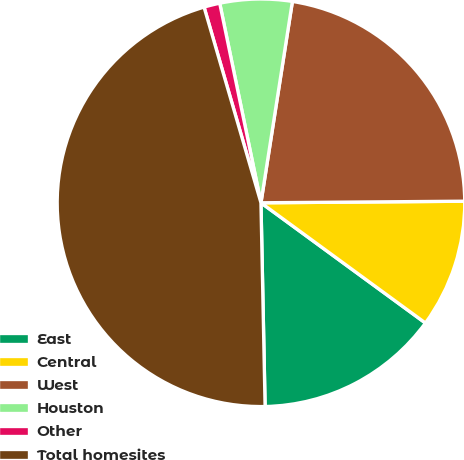<chart> <loc_0><loc_0><loc_500><loc_500><pie_chart><fcel>East<fcel>Central<fcel>West<fcel>Houston<fcel>Other<fcel>Total homesites<nl><fcel>14.63%<fcel>10.17%<fcel>22.41%<fcel>5.71%<fcel>1.26%<fcel>45.82%<nl></chart> 